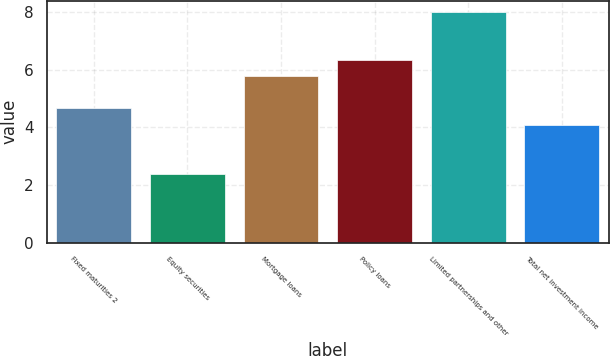<chart> <loc_0><loc_0><loc_500><loc_500><bar_chart><fcel>Fixed maturities 2<fcel>Equity securities<fcel>Mortgage loans<fcel>Policy loans<fcel>Limited partnerships and other<fcel>Total net investment income<nl><fcel>4.66<fcel>2.4<fcel>5.78<fcel>6.34<fcel>8<fcel>4.1<nl></chart> 